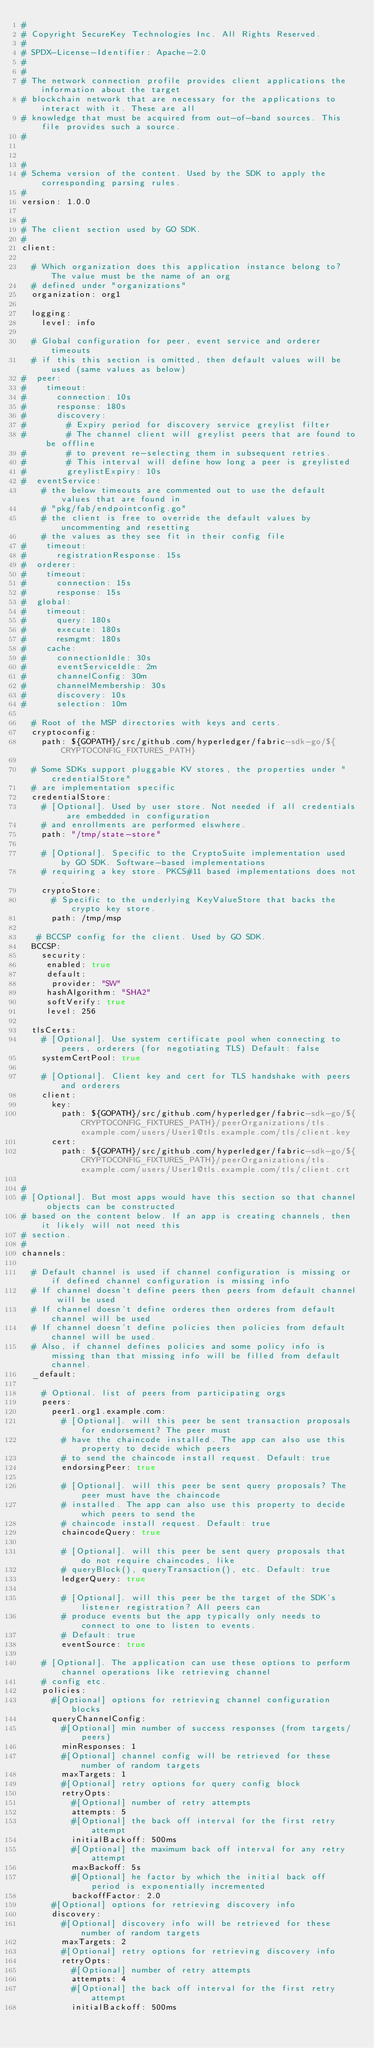Convert code to text. <code><loc_0><loc_0><loc_500><loc_500><_YAML_>#
# Copyright SecureKey Technologies Inc. All Rights Reserved.
#
# SPDX-License-Identifier: Apache-2.0
#
#
# The network connection profile provides client applications the information about the target
# blockchain network that are necessary for the applications to interact with it. These are all
# knowledge that must be acquired from out-of-band sources. This file provides such a source.
#


#
# Schema version of the content. Used by the SDK to apply the corresponding parsing rules.
#
version: 1.0.0

#
# The client section used by GO SDK.
#
client:

  # Which organization does this application instance belong to? The value must be the name of an org
  # defined under "organizations"
  organization: org1

  logging:
    level: info

  # Global configuration for peer, event service and orderer timeouts
  # if this this section is omitted, then default values will be used (same values as below)
#  peer:
#    timeout:
#      connection: 10s
#      response: 180s
#      discovery:
#        # Expiry period for discovery service greylist filter
#        # The channel client will greylist peers that are found to be offline
#        # to prevent re-selecting them in subsequent retries.
#        # This interval will define how long a peer is greylisted
#        greylistExpiry: 10s
#  eventService:
    # the below timeouts are commented out to use the default values that are found in
    # "pkg/fab/endpointconfig.go"
    # the client is free to override the default values by uncommenting and resetting
    # the values as they see fit in their config file
#    timeout:
#      registrationResponse: 15s
#  orderer:
#    timeout:
#      connection: 15s
#      response: 15s
#  global:
#    timeout:
#      query: 180s
#      execute: 180s
#      resmgmt: 180s
#    cache:
#      connectionIdle: 30s
#      eventServiceIdle: 2m
#      channelConfig: 30m
#      channelMembership: 30s
#      discovery: 10s
#      selection: 10m

  # Root of the MSP directories with keys and certs.
  cryptoconfig:
    path: ${GOPATH}/src/github.com/hyperledger/fabric-sdk-go/${CRYPTOCONFIG_FIXTURES_PATH}

  # Some SDKs support pluggable KV stores, the properties under "credentialStore"
  # are implementation specific
  credentialStore:
    # [Optional]. Used by user store. Not needed if all credentials are embedded in configuration
    # and enrollments are performed elswhere.
    path: "/tmp/state-store"

    # [Optional]. Specific to the CryptoSuite implementation used by GO SDK. Software-based implementations
    # requiring a key store. PKCS#11 based implementations does not.
    cryptoStore:
      # Specific to the underlying KeyValueStore that backs the crypto key store.
      path: /tmp/msp

   # BCCSP config for the client. Used by GO SDK.
  BCCSP:
    security:
     enabled: true
     default:
      provider: "SW"
     hashAlgorithm: "SHA2"
     softVerify: true
     level: 256

  tlsCerts:
    # [Optional]. Use system certificate pool when connecting to peers, orderers (for negotiating TLS) Default: false
    systemCertPool: true

    # [Optional]. Client key and cert for TLS handshake with peers and orderers
    client:
      key:
        path: ${GOPATH}/src/github.com/hyperledger/fabric-sdk-go/${CRYPTOCONFIG_FIXTURES_PATH}/peerOrganizations/tls.example.com/users/User1@tls.example.com/tls/client.key
      cert:
        path: ${GOPATH}/src/github.com/hyperledger/fabric-sdk-go/${CRYPTOCONFIG_FIXTURES_PATH}/peerOrganizations/tls.example.com/users/User1@tls.example.com/tls/client.crt

#
# [Optional]. But most apps would have this section so that channel objects can be constructed
# based on the content below. If an app is creating channels, then it likely will not need this
# section.
#
channels:

  # Default channel is used if channel configuration is missing or if defined channel configuration is missing info
  # If channel doesn't define peers then peers from default channel will be used
  # If channel doesn't define orderes then orderes from default channel will be used
  # If channel doesn't define policies then policies from default channel will be used. 
  # Also, if channel defines policies and some policy info is missing than that missing info will be filled from default channel.
  _default:

    # Optional. list of peers from participating orgs
    peers:
      peer1.org1.example.com:
        # [Optional]. will this peer be sent transaction proposals for endorsement? The peer must
        # have the chaincode installed. The app can also use this property to decide which peers
        # to send the chaincode install request. Default: true
        endorsingPeer: true

        # [Optional]. will this peer be sent query proposals? The peer must have the chaincode
        # installed. The app can also use this property to decide which peers to send the
        # chaincode install request. Default: true
        chaincodeQuery: true

        # [Optional]. will this peer be sent query proposals that do not require chaincodes, like
        # queryBlock(), queryTransaction(), etc. Default: true
        ledgerQuery: true

        # [Optional]. will this peer be the target of the SDK's listener registration? All peers can
        # produce events but the app typically only needs to connect to one to listen to events.
        # Default: true
        eventSource: true

    # [Optional]. The application can use these options to perform channel operations like retrieving channel
    # config etc.
    policies:
      #[Optional] options for retrieving channel configuration blocks
      queryChannelConfig:
        #[Optional] min number of success responses (from targets/peers)
        minResponses: 1
        #[Optional] channel config will be retrieved for these number of random targets
        maxTargets: 1
        #[Optional] retry options for query config block
        retryOpts:
          #[Optional] number of retry attempts
          attempts: 5
          #[Optional] the back off interval for the first retry attempt
          initialBackoff: 500ms
          #[Optional] the maximum back off interval for any retry attempt
          maxBackoff: 5s
          #[Optional] he factor by which the initial back off period is exponentially incremented
          backoffFactor: 2.0
      #[Optional] options for retrieving discovery info
      discovery:
        #[Optional] discovery info will be retrieved for these number of random targets
        maxTargets: 2
        #[Optional] retry options for retrieving discovery info
        retryOpts:
          #[Optional] number of retry attempts
          attempts: 4
          #[Optional] the back off interval for the first retry attempt
          initialBackoff: 500ms</code> 